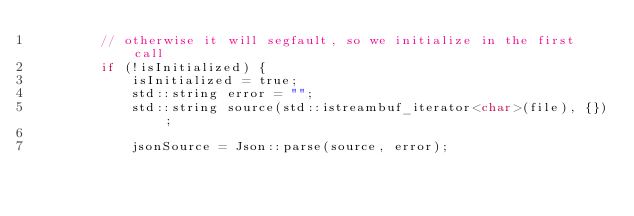Convert code to text. <code><loc_0><loc_0><loc_500><loc_500><_C_>        // otherwise it will segfault, so we initialize in the first call
        if (!isInitialized) {
            isInitialized = true;
            std::string error = "";
            std::string source(std::istreambuf_iterator<char>(file), {});

            jsonSource = Json::parse(source, error);</code> 